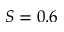Convert formula to latex. <formula><loc_0><loc_0><loc_500><loc_500>S = 0 . 6</formula> 